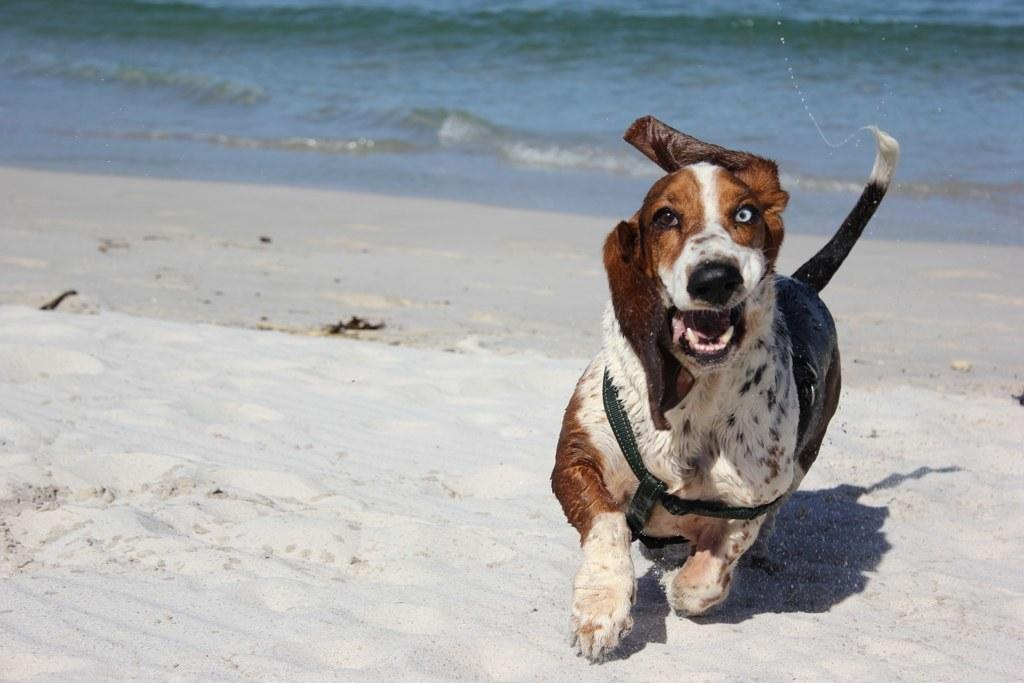What is the main subject in the foreground of the image? There is a dog in the foreground of the image. What type of terrain is visible at the bottom of the image? There is sand at the bottom of the image. What natural feature can be seen in the background of the image? There is a river visible in the background of the image. What is the name of the daughter in the image? There is no daughter present in the image; it features a dog in the foreground. What process is being used to create the sand in the image? The image does not show any process being used to create the sand; it is a natural terrain feature. 